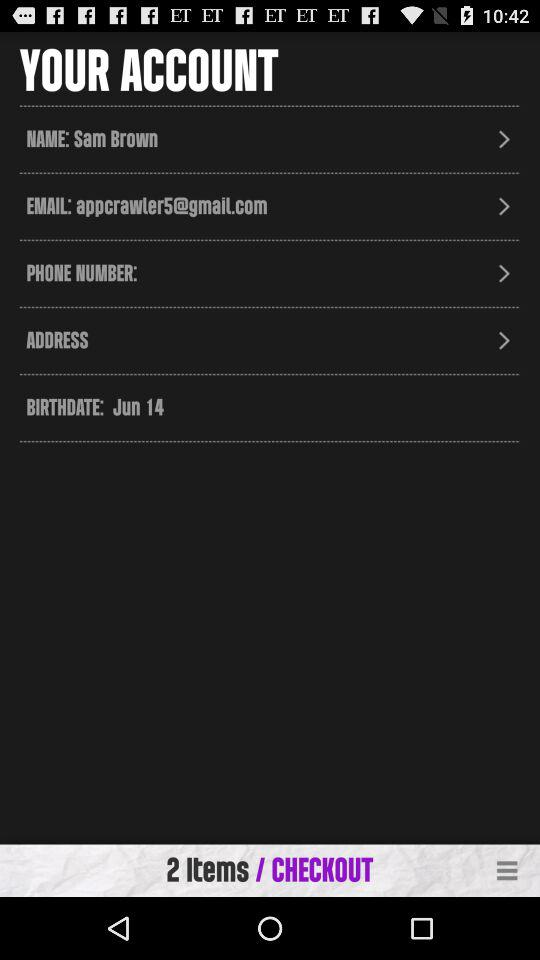What is the email address? The email address is appcrawler5@gmail.com. 